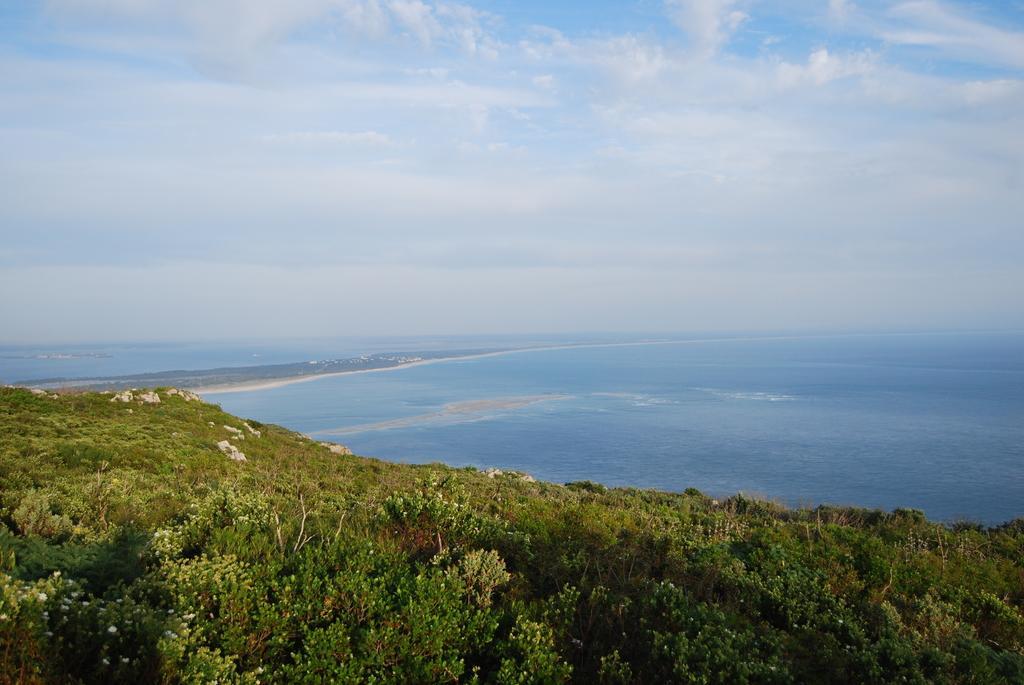Could you give a brief overview of what you see in this image? In this picture we can see trees, water and sky with clouds. 